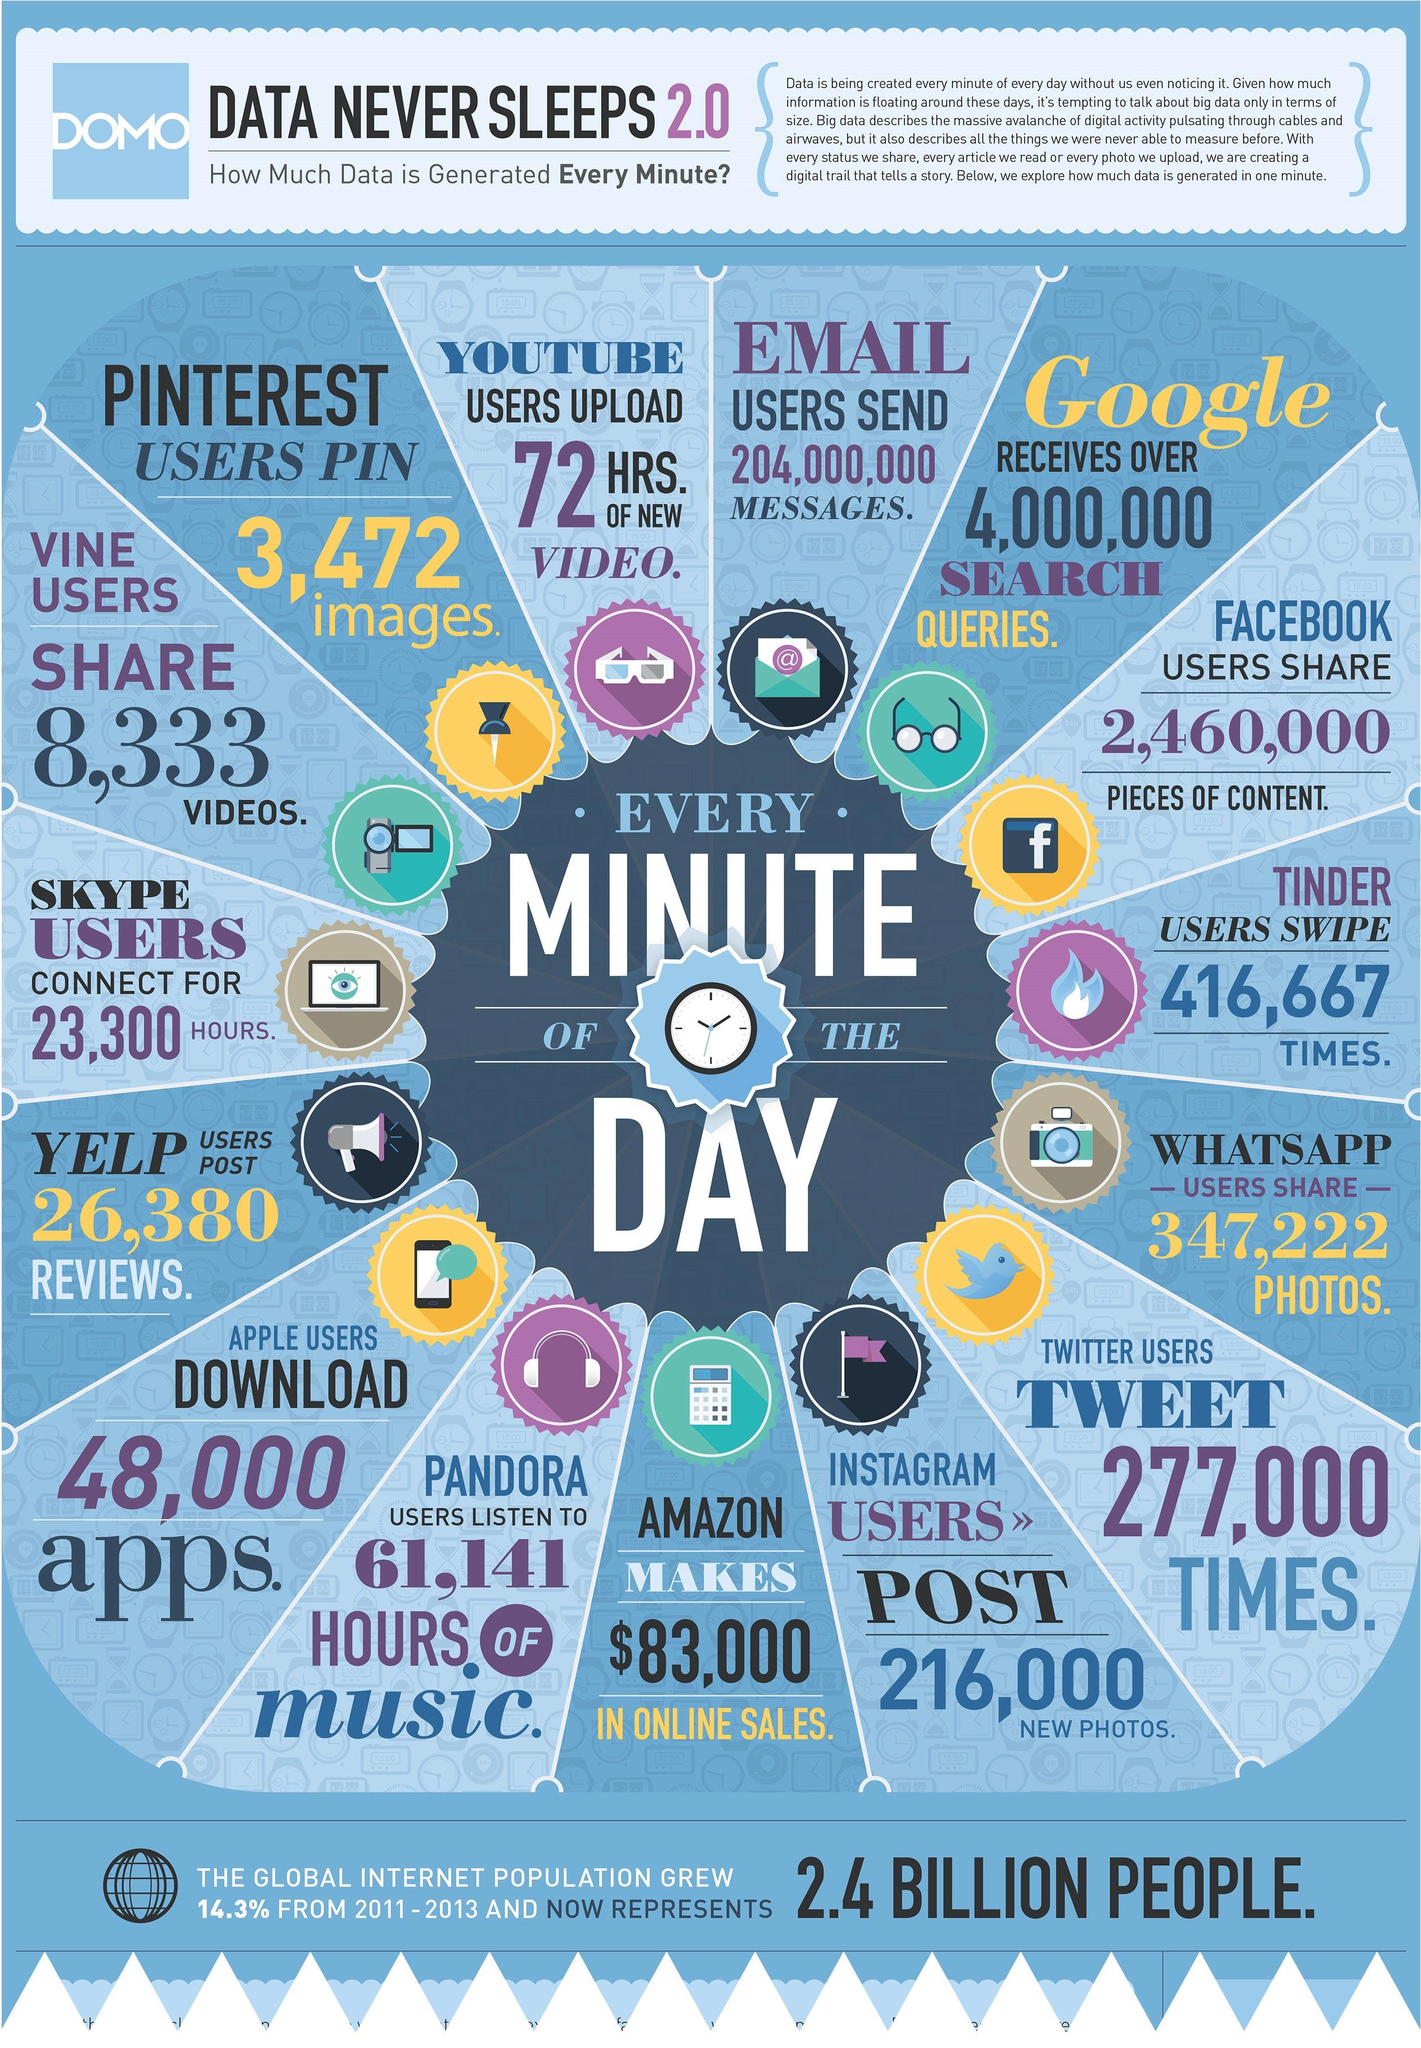Identify some key points in this picture. Each minute, YouTube users upload an average of 72 hours of new videos. Google receives over 4,000,000 search queries every minute of the day. On average, 216,000 new photos were posted by Instagram users every minute of the day. There were approximately 26,380 reviews posted by Yelp users every minute of the day. Amazon generates approximately $83,000 in online sales every minute of the day. 